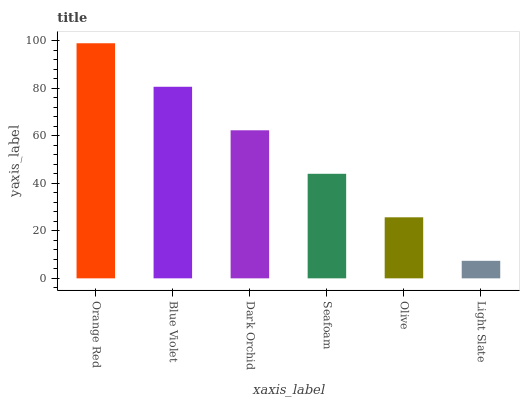Is Blue Violet the minimum?
Answer yes or no. No. Is Blue Violet the maximum?
Answer yes or no. No. Is Orange Red greater than Blue Violet?
Answer yes or no. Yes. Is Blue Violet less than Orange Red?
Answer yes or no. Yes. Is Blue Violet greater than Orange Red?
Answer yes or no. No. Is Orange Red less than Blue Violet?
Answer yes or no. No. Is Dark Orchid the high median?
Answer yes or no. Yes. Is Seafoam the low median?
Answer yes or no. Yes. Is Light Slate the high median?
Answer yes or no. No. Is Dark Orchid the low median?
Answer yes or no. No. 